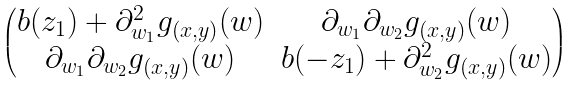<formula> <loc_0><loc_0><loc_500><loc_500>\begin{pmatrix} b ( z _ { 1 } ) + \partial _ { w _ { 1 } } ^ { 2 } g _ { ( x , y ) } ( w ) & \partial _ { w _ { 1 } } \partial _ { w _ { 2 } } g _ { ( x , y ) } ( w ) \\ \partial _ { w _ { 1 } } \partial _ { w _ { 2 } } g _ { ( x , y ) } ( w ) & b ( - z _ { 1 } ) + \partial _ { w _ { 2 } } ^ { 2 } g _ { ( x , y ) } ( w ) \end{pmatrix}</formula> 